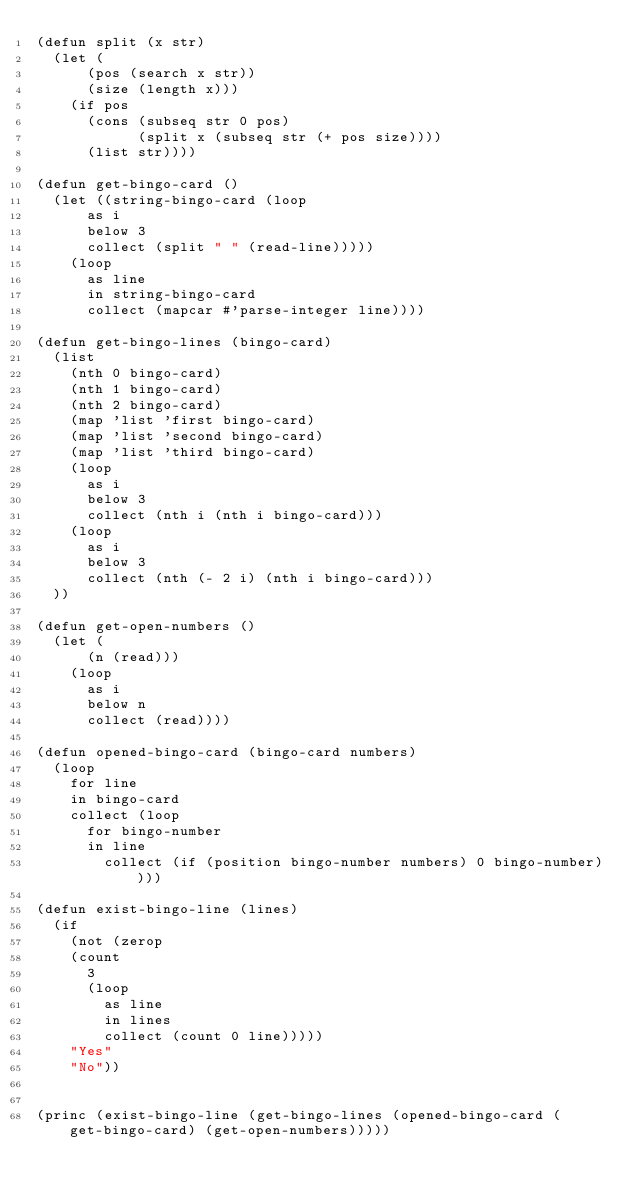<code> <loc_0><loc_0><loc_500><loc_500><_Lisp_>(defun split (x str)
  (let (
      (pos (search x str))
      (size (length x)))
    (if pos
      (cons (subseq str 0 pos)
            (split x (subseq str (+ pos size))))
      (list str))))

(defun get-bingo-card ()
  (let ((string-bingo-card (loop 
      as i 
      below 3
      collect (split " " (read-line)))))
    (loop
      as line
      in string-bingo-card
      collect (mapcar #'parse-integer line))))

(defun get-bingo-lines (bingo-card)
  (list
    (nth 0 bingo-card)
    (nth 1 bingo-card)
    (nth 2 bingo-card)
    (map 'list 'first bingo-card)
    (map 'list 'second bingo-card)
    (map 'list 'third bingo-card)
    (loop
      as i
      below 3
      collect (nth i (nth i bingo-card)))
    (loop
      as i
      below 3
      collect (nth (- 2 i) (nth i bingo-card)))
  ))

(defun get-open-numbers ()
  (let (
      (n (read)))
    (loop
      as i
      below n
      collect (read))))

(defun opened-bingo-card (bingo-card numbers)
  (loop
    for line
    in bingo-card
    collect (loop
      for bingo-number
      in line
	    collect (if (position bingo-number numbers) 0 bingo-number))))

(defun exist-bingo-line (lines)
  (if
    (not (zerop 
    (count 
      3
      (loop
        as line
        in lines
        collect (count 0 line)))))
    "Yes"
    "No"))
  

(princ (exist-bingo-line (get-bingo-lines (opened-bingo-card (get-bingo-card) (get-open-numbers)))))</code> 